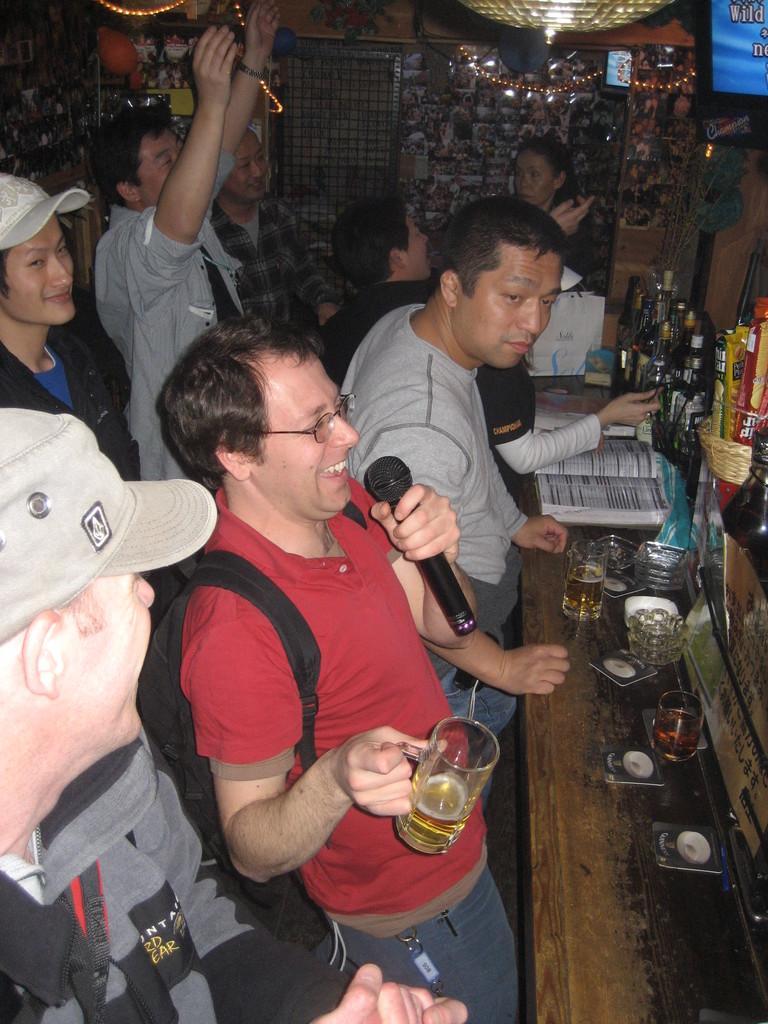Could you give a brief overview of what you see in this image? In this image I can see few people are standing. Here I can see two of them are wearing caps. I can also see smile on few faces and here he is holding a glass, a mic and wearing a specs. On this table I can see few glasses, a book and few bottles. 